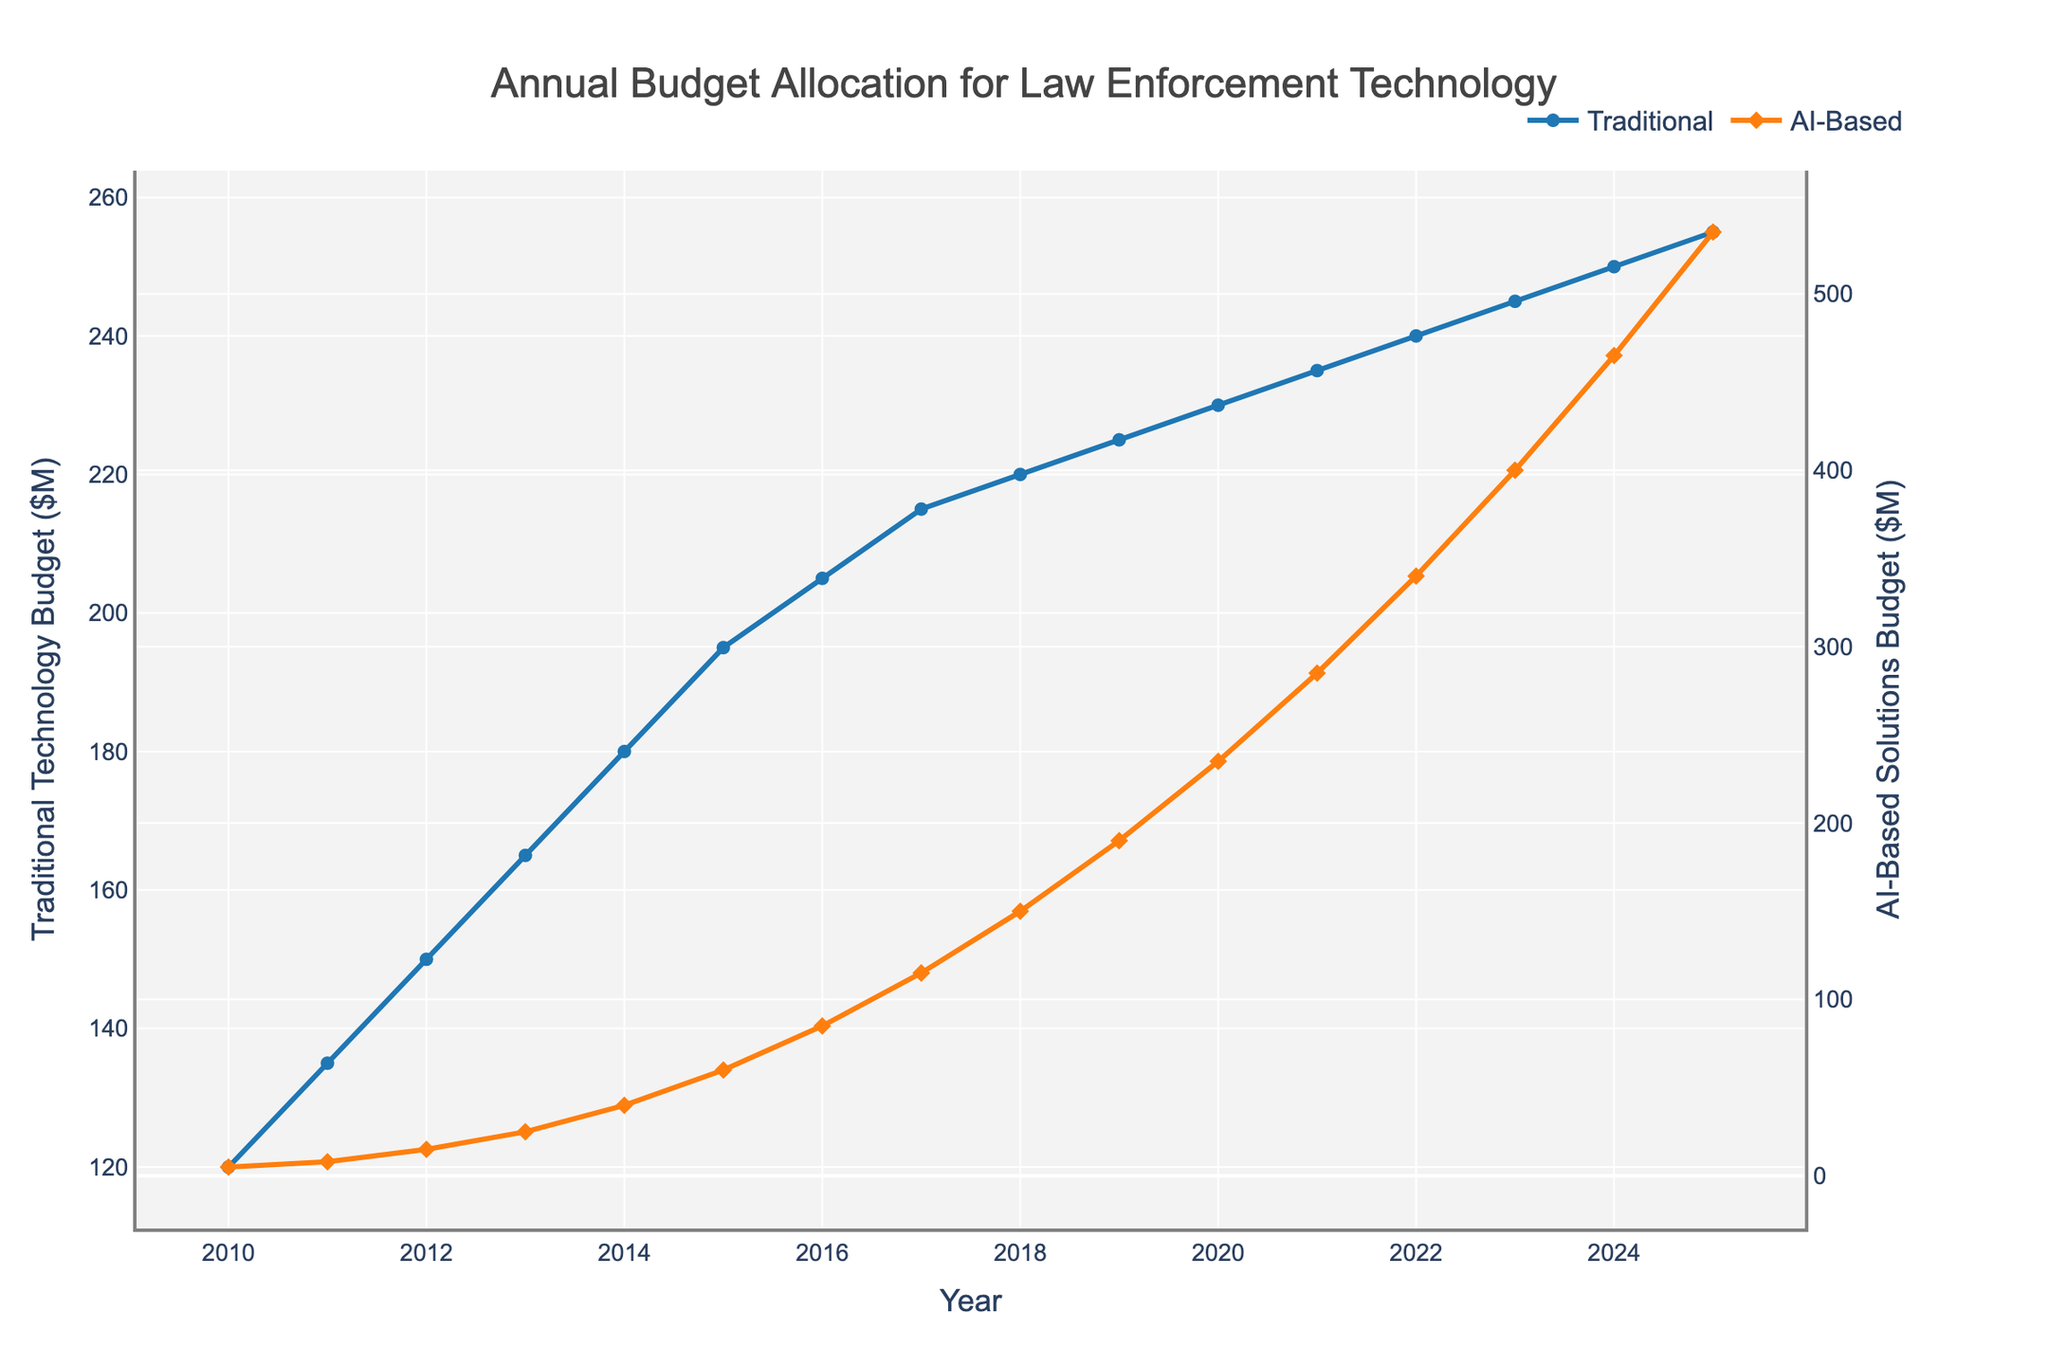what is the total budget in 2023 for both traditional technology and AI-based solutions? The budget in 2023 for traditional technology is $245M and for AI-based solutions is $400M. Adding these amounts will give the total budget for 2023. Total budget = $245M + $400M = $645M
Answer: $645M How does the AI-based budget in 2015 compare to the traditional technology budget in the same year? The budget for traditional technology in 2015 is $195M, while the budget for AI-based solutions in 2015 is $60M. Comparing these, traditional technology has a significantly higher budget.
Answer: Traditional technology budget is higher Which year shows the greatest percentage increase in AI-based solutions budget compared to the previous year? To find the year with the greatest percentage increase, calculate the year-over-year percentage change for AI-based solutions budget each year and compare them. The years 2010 to 2011 show an increase from $5M to $8M, which is a 60% increase, the greatest among all years.
Answer: 2011 What is the difference in budget allocation between traditional technology and AI-based solutions in 2025? The traditional technology budget in 2025 is $255M, and the AI-based solutions budget is $535M. The difference is $535M - $255M = $280M.
Answer: $280M In what year does the AI-based solutions budget exceed the traditional technology budget for the first time? By checking the data year by year, the AI-based solutions budget first exceeds the traditional technology budget in 2022, where the AI-based budget is $340M compared to traditional technology at $240M.
Answer: 2022 Which category shows a more consistent increment in budget year over year? Examining the year-over-year values for both categories, the traditional technology budget increases steadily by a small amount each year, while the AI-based solutions budget has larger, more variable increases.
Answer: Traditional technology Between which consecutive years did traditional technology see the smallest increase in budget? Looking at the year-over-year changes, the smallest increase in the traditional technology budget is from 2023 to 2024, where it increases from $245M to $250M, an increase of just $5M.
Answer: 2023 to 2024 What can be observed about the trends of both budgets from 2018 to 2022? From 2018 to 2022, the budget for traditional technology slightly increases, whereas the AI-based solutions budget shows significant and rapid growth. The trend suggests a focus shift towards AI-based solutions in the given years.
Answer: AI-based budget grows rapidly, traditional slightly increases 